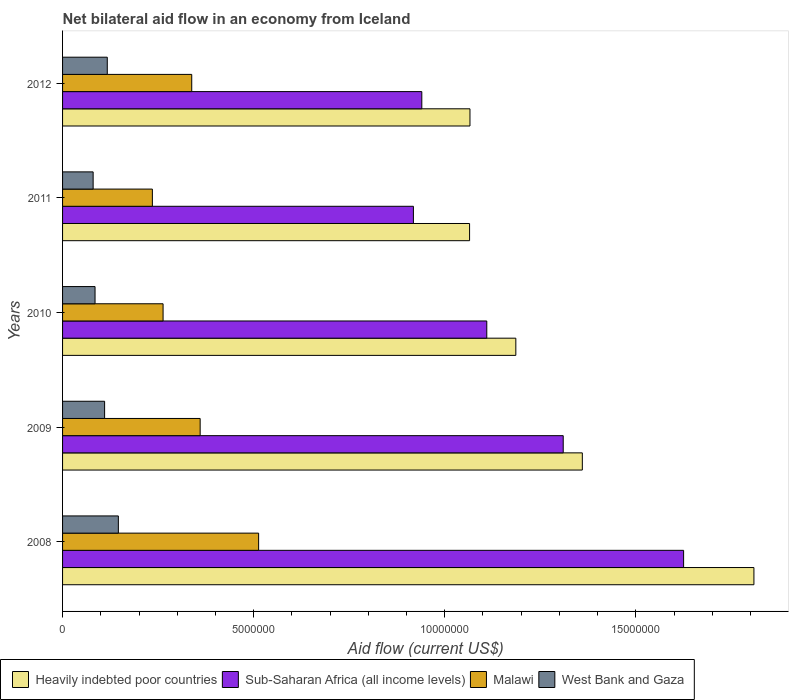How many different coloured bars are there?
Provide a succinct answer. 4. How many bars are there on the 3rd tick from the top?
Your answer should be compact. 4. How many bars are there on the 1st tick from the bottom?
Make the answer very short. 4. In how many cases, is the number of bars for a given year not equal to the number of legend labels?
Your response must be concise. 0. What is the net bilateral aid flow in Sub-Saharan Africa (all income levels) in 2011?
Provide a succinct answer. 9.18e+06. Across all years, what is the maximum net bilateral aid flow in Malawi?
Your answer should be very brief. 5.13e+06. Across all years, what is the minimum net bilateral aid flow in Sub-Saharan Africa (all income levels)?
Offer a very short reply. 9.18e+06. In which year was the net bilateral aid flow in Sub-Saharan Africa (all income levels) minimum?
Your answer should be compact. 2011. What is the total net bilateral aid flow in West Bank and Gaza in the graph?
Ensure brevity in your answer.  5.38e+06. What is the difference between the net bilateral aid flow in Malawi in 2008 and that in 2012?
Your response must be concise. 1.75e+06. What is the difference between the net bilateral aid flow in Malawi in 2008 and the net bilateral aid flow in Sub-Saharan Africa (all income levels) in 2012?
Your answer should be very brief. -4.27e+06. What is the average net bilateral aid flow in West Bank and Gaza per year?
Provide a succinct answer. 1.08e+06. In the year 2012, what is the difference between the net bilateral aid flow in Heavily indebted poor countries and net bilateral aid flow in West Bank and Gaza?
Offer a terse response. 9.49e+06. In how many years, is the net bilateral aid flow in Heavily indebted poor countries greater than 7000000 US$?
Keep it short and to the point. 5. What is the ratio of the net bilateral aid flow in Malawi in 2010 to that in 2011?
Offer a terse response. 1.12. What is the difference between the highest and the second highest net bilateral aid flow in Heavily indebted poor countries?
Make the answer very short. 4.49e+06. In how many years, is the net bilateral aid flow in Heavily indebted poor countries greater than the average net bilateral aid flow in Heavily indebted poor countries taken over all years?
Your answer should be very brief. 2. What does the 2nd bar from the top in 2012 represents?
Your answer should be very brief. Malawi. What does the 4th bar from the bottom in 2011 represents?
Ensure brevity in your answer.  West Bank and Gaza. Are all the bars in the graph horizontal?
Provide a succinct answer. Yes. How many years are there in the graph?
Offer a terse response. 5. How are the legend labels stacked?
Your answer should be very brief. Horizontal. What is the title of the graph?
Provide a succinct answer. Net bilateral aid flow in an economy from Iceland. Does "Burkina Faso" appear as one of the legend labels in the graph?
Provide a short and direct response. No. What is the label or title of the X-axis?
Give a very brief answer. Aid flow (current US$). What is the label or title of the Y-axis?
Your answer should be very brief. Years. What is the Aid flow (current US$) in Heavily indebted poor countries in 2008?
Provide a short and direct response. 1.81e+07. What is the Aid flow (current US$) of Sub-Saharan Africa (all income levels) in 2008?
Your response must be concise. 1.62e+07. What is the Aid flow (current US$) in Malawi in 2008?
Ensure brevity in your answer.  5.13e+06. What is the Aid flow (current US$) in West Bank and Gaza in 2008?
Provide a short and direct response. 1.46e+06. What is the Aid flow (current US$) of Heavily indebted poor countries in 2009?
Provide a short and direct response. 1.36e+07. What is the Aid flow (current US$) in Sub-Saharan Africa (all income levels) in 2009?
Your response must be concise. 1.31e+07. What is the Aid flow (current US$) in Malawi in 2009?
Offer a very short reply. 3.60e+06. What is the Aid flow (current US$) of West Bank and Gaza in 2009?
Offer a very short reply. 1.10e+06. What is the Aid flow (current US$) of Heavily indebted poor countries in 2010?
Your response must be concise. 1.19e+07. What is the Aid flow (current US$) of Sub-Saharan Africa (all income levels) in 2010?
Your answer should be compact. 1.11e+07. What is the Aid flow (current US$) of Malawi in 2010?
Your answer should be very brief. 2.63e+06. What is the Aid flow (current US$) of West Bank and Gaza in 2010?
Offer a very short reply. 8.50e+05. What is the Aid flow (current US$) of Heavily indebted poor countries in 2011?
Give a very brief answer. 1.06e+07. What is the Aid flow (current US$) of Sub-Saharan Africa (all income levels) in 2011?
Your response must be concise. 9.18e+06. What is the Aid flow (current US$) in Malawi in 2011?
Ensure brevity in your answer.  2.35e+06. What is the Aid flow (current US$) in Heavily indebted poor countries in 2012?
Your answer should be compact. 1.07e+07. What is the Aid flow (current US$) in Sub-Saharan Africa (all income levels) in 2012?
Your answer should be very brief. 9.40e+06. What is the Aid flow (current US$) in Malawi in 2012?
Ensure brevity in your answer.  3.38e+06. What is the Aid flow (current US$) of West Bank and Gaza in 2012?
Offer a very short reply. 1.17e+06. Across all years, what is the maximum Aid flow (current US$) in Heavily indebted poor countries?
Provide a succinct answer. 1.81e+07. Across all years, what is the maximum Aid flow (current US$) of Sub-Saharan Africa (all income levels)?
Offer a terse response. 1.62e+07. Across all years, what is the maximum Aid flow (current US$) in Malawi?
Provide a succinct answer. 5.13e+06. Across all years, what is the maximum Aid flow (current US$) of West Bank and Gaza?
Your answer should be very brief. 1.46e+06. Across all years, what is the minimum Aid flow (current US$) of Heavily indebted poor countries?
Offer a very short reply. 1.06e+07. Across all years, what is the minimum Aid flow (current US$) of Sub-Saharan Africa (all income levels)?
Make the answer very short. 9.18e+06. Across all years, what is the minimum Aid flow (current US$) of Malawi?
Make the answer very short. 2.35e+06. What is the total Aid flow (current US$) in Heavily indebted poor countries in the graph?
Give a very brief answer. 6.49e+07. What is the total Aid flow (current US$) of Sub-Saharan Africa (all income levels) in the graph?
Your answer should be very brief. 5.90e+07. What is the total Aid flow (current US$) in Malawi in the graph?
Give a very brief answer. 1.71e+07. What is the total Aid flow (current US$) in West Bank and Gaza in the graph?
Give a very brief answer. 5.38e+06. What is the difference between the Aid flow (current US$) in Heavily indebted poor countries in 2008 and that in 2009?
Provide a succinct answer. 4.49e+06. What is the difference between the Aid flow (current US$) of Sub-Saharan Africa (all income levels) in 2008 and that in 2009?
Your answer should be very brief. 3.15e+06. What is the difference between the Aid flow (current US$) of Malawi in 2008 and that in 2009?
Provide a succinct answer. 1.53e+06. What is the difference between the Aid flow (current US$) in Heavily indebted poor countries in 2008 and that in 2010?
Your answer should be very brief. 6.23e+06. What is the difference between the Aid flow (current US$) in Sub-Saharan Africa (all income levels) in 2008 and that in 2010?
Your response must be concise. 5.15e+06. What is the difference between the Aid flow (current US$) of Malawi in 2008 and that in 2010?
Provide a short and direct response. 2.50e+06. What is the difference between the Aid flow (current US$) of Heavily indebted poor countries in 2008 and that in 2011?
Your answer should be very brief. 7.44e+06. What is the difference between the Aid flow (current US$) of Sub-Saharan Africa (all income levels) in 2008 and that in 2011?
Ensure brevity in your answer.  7.07e+06. What is the difference between the Aid flow (current US$) of Malawi in 2008 and that in 2011?
Ensure brevity in your answer.  2.78e+06. What is the difference between the Aid flow (current US$) in Heavily indebted poor countries in 2008 and that in 2012?
Provide a short and direct response. 7.43e+06. What is the difference between the Aid flow (current US$) of Sub-Saharan Africa (all income levels) in 2008 and that in 2012?
Make the answer very short. 6.85e+06. What is the difference between the Aid flow (current US$) of Malawi in 2008 and that in 2012?
Make the answer very short. 1.75e+06. What is the difference between the Aid flow (current US$) of West Bank and Gaza in 2008 and that in 2012?
Provide a succinct answer. 2.90e+05. What is the difference between the Aid flow (current US$) of Heavily indebted poor countries in 2009 and that in 2010?
Keep it short and to the point. 1.74e+06. What is the difference between the Aid flow (current US$) of Sub-Saharan Africa (all income levels) in 2009 and that in 2010?
Give a very brief answer. 2.00e+06. What is the difference between the Aid flow (current US$) in Malawi in 2009 and that in 2010?
Your answer should be very brief. 9.70e+05. What is the difference between the Aid flow (current US$) of West Bank and Gaza in 2009 and that in 2010?
Make the answer very short. 2.50e+05. What is the difference between the Aid flow (current US$) of Heavily indebted poor countries in 2009 and that in 2011?
Provide a succinct answer. 2.95e+06. What is the difference between the Aid flow (current US$) in Sub-Saharan Africa (all income levels) in 2009 and that in 2011?
Your answer should be very brief. 3.92e+06. What is the difference between the Aid flow (current US$) in Malawi in 2009 and that in 2011?
Your answer should be very brief. 1.25e+06. What is the difference between the Aid flow (current US$) in West Bank and Gaza in 2009 and that in 2011?
Offer a terse response. 3.00e+05. What is the difference between the Aid flow (current US$) of Heavily indebted poor countries in 2009 and that in 2012?
Keep it short and to the point. 2.94e+06. What is the difference between the Aid flow (current US$) in Sub-Saharan Africa (all income levels) in 2009 and that in 2012?
Your answer should be very brief. 3.70e+06. What is the difference between the Aid flow (current US$) of Malawi in 2009 and that in 2012?
Keep it short and to the point. 2.20e+05. What is the difference between the Aid flow (current US$) of Heavily indebted poor countries in 2010 and that in 2011?
Keep it short and to the point. 1.21e+06. What is the difference between the Aid flow (current US$) in Sub-Saharan Africa (all income levels) in 2010 and that in 2011?
Provide a short and direct response. 1.92e+06. What is the difference between the Aid flow (current US$) of West Bank and Gaza in 2010 and that in 2011?
Give a very brief answer. 5.00e+04. What is the difference between the Aid flow (current US$) in Heavily indebted poor countries in 2010 and that in 2012?
Provide a short and direct response. 1.20e+06. What is the difference between the Aid flow (current US$) of Sub-Saharan Africa (all income levels) in 2010 and that in 2012?
Provide a succinct answer. 1.70e+06. What is the difference between the Aid flow (current US$) of Malawi in 2010 and that in 2012?
Make the answer very short. -7.50e+05. What is the difference between the Aid flow (current US$) of West Bank and Gaza in 2010 and that in 2012?
Offer a very short reply. -3.20e+05. What is the difference between the Aid flow (current US$) in Heavily indebted poor countries in 2011 and that in 2012?
Keep it short and to the point. -10000. What is the difference between the Aid flow (current US$) in Sub-Saharan Africa (all income levels) in 2011 and that in 2012?
Offer a very short reply. -2.20e+05. What is the difference between the Aid flow (current US$) of Malawi in 2011 and that in 2012?
Your response must be concise. -1.03e+06. What is the difference between the Aid flow (current US$) of West Bank and Gaza in 2011 and that in 2012?
Provide a succinct answer. -3.70e+05. What is the difference between the Aid flow (current US$) in Heavily indebted poor countries in 2008 and the Aid flow (current US$) in Sub-Saharan Africa (all income levels) in 2009?
Your response must be concise. 4.99e+06. What is the difference between the Aid flow (current US$) of Heavily indebted poor countries in 2008 and the Aid flow (current US$) of Malawi in 2009?
Offer a terse response. 1.45e+07. What is the difference between the Aid flow (current US$) of Heavily indebted poor countries in 2008 and the Aid flow (current US$) of West Bank and Gaza in 2009?
Keep it short and to the point. 1.70e+07. What is the difference between the Aid flow (current US$) in Sub-Saharan Africa (all income levels) in 2008 and the Aid flow (current US$) in Malawi in 2009?
Offer a very short reply. 1.26e+07. What is the difference between the Aid flow (current US$) of Sub-Saharan Africa (all income levels) in 2008 and the Aid flow (current US$) of West Bank and Gaza in 2009?
Offer a very short reply. 1.52e+07. What is the difference between the Aid flow (current US$) of Malawi in 2008 and the Aid flow (current US$) of West Bank and Gaza in 2009?
Keep it short and to the point. 4.03e+06. What is the difference between the Aid flow (current US$) in Heavily indebted poor countries in 2008 and the Aid flow (current US$) in Sub-Saharan Africa (all income levels) in 2010?
Your response must be concise. 6.99e+06. What is the difference between the Aid flow (current US$) in Heavily indebted poor countries in 2008 and the Aid flow (current US$) in Malawi in 2010?
Give a very brief answer. 1.55e+07. What is the difference between the Aid flow (current US$) in Heavily indebted poor countries in 2008 and the Aid flow (current US$) in West Bank and Gaza in 2010?
Make the answer very short. 1.72e+07. What is the difference between the Aid flow (current US$) in Sub-Saharan Africa (all income levels) in 2008 and the Aid flow (current US$) in Malawi in 2010?
Your answer should be compact. 1.36e+07. What is the difference between the Aid flow (current US$) of Sub-Saharan Africa (all income levels) in 2008 and the Aid flow (current US$) of West Bank and Gaza in 2010?
Your answer should be compact. 1.54e+07. What is the difference between the Aid flow (current US$) in Malawi in 2008 and the Aid flow (current US$) in West Bank and Gaza in 2010?
Provide a succinct answer. 4.28e+06. What is the difference between the Aid flow (current US$) in Heavily indebted poor countries in 2008 and the Aid flow (current US$) in Sub-Saharan Africa (all income levels) in 2011?
Offer a very short reply. 8.91e+06. What is the difference between the Aid flow (current US$) of Heavily indebted poor countries in 2008 and the Aid flow (current US$) of Malawi in 2011?
Provide a short and direct response. 1.57e+07. What is the difference between the Aid flow (current US$) in Heavily indebted poor countries in 2008 and the Aid flow (current US$) in West Bank and Gaza in 2011?
Provide a short and direct response. 1.73e+07. What is the difference between the Aid flow (current US$) in Sub-Saharan Africa (all income levels) in 2008 and the Aid flow (current US$) in Malawi in 2011?
Your answer should be compact. 1.39e+07. What is the difference between the Aid flow (current US$) of Sub-Saharan Africa (all income levels) in 2008 and the Aid flow (current US$) of West Bank and Gaza in 2011?
Make the answer very short. 1.54e+07. What is the difference between the Aid flow (current US$) in Malawi in 2008 and the Aid flow (current US$) in West Bank and Gaza in 2011?
Your answer should be compact. 4.33e+06. What is the difference between the Aid flow (current US$) of Heavily indebted poor countries in 2008 and the Aid flow (current US$) of Sub-Saharan Africa (all income levels) in 2012?
Your answer should be compact. 8.69e+06. What is the difference between the Aid flow (current US$) in Heavily indebted poor countries in 2008 and the Aid flow (current US$) in Malawi in 2012?
Make the answer very short. 1.47e+07. What is the difference between the Aid flow (current US$) in Heavily indebted poor countries in 2008 and the Aid flow (current US$) in West Bank and Gaza in 2012?
Provide a succinct answer. 1.69e+07. What is the difference between the Aid flow (current US$) of Sub-Saharan Africa (all income levels) in 2008 and the Aid flow (current US$) of Malawi in 2012?
Your answer should be compact. 1.29e+07. What is the difference between the Aid flow (current US$) in Sub-Saharan Africa (all income levels) in 2008 and the Aid flow (current US$) in West Bank and Gaza in 2012?
Make the answer very short. 1.51e+07. What is the difference between the Aid flow (current US$) of Malawi in 2008 and the Aid flow (current US$) of West Bank and Gaza in 2012?
Provide a succinct answer. 3.96e+06. What is the difference between the Aid flow (current US$) of Heavily indebted poor countries in 2009 and the Aid flow (current US$) of Sub-Saharan Africa (all income levels) in 2010?
Make the answer very short. 2.50e+06. What is the difference between the Aid flow (current US$) of Heavily indebted poor countries in 2009 and the Aid flow (current US$) of Malawi in 2010?
Ensure brevity in your answer.  1.10e+07. What is the difference between the Aid flow (current US$) in Heavily indebted poor countries in 2009 and the Aid flow (current US$) in West Bank and Gaza in 2010?
Provide a succinct answer. 1.28e+07. What is the difference between the Aid flow (current US$) in Sub-Saharan Africa (all income levels) in 2009 and the Aid flow (current US$) in Malawi in 2010?
Offer a terse response. 1.05e+07. What is the difference between the Aid flow (current US$) of Sub-Saharan Africa (all income levels) in 2009 and the Aid flow (current US$) of West Bank and Gaza in 2010?
Your answer should be very brief. 1.22e+07. What is the difference between the Aid flow (current US$) of Malawi in 2009 and the Aid flow (current US$) of West Bank and Gaza in 2010?
Provide a succinct answer. 2.75e+06. What is the difference between the Aid flow (current US$) in Heavily indebted poor countries in 2009 and the Aid flow (current US$) in Sub-Saharan Africa (all income levels) in 2011?
Give a very brief answer. 4.42e+06. What is the difference between the Aid flow (current US$) of Heavily indebted poor countries in 2009 and the Aid flow (current US$) of Malawi in 2011?
Your answer should be very brief. 1.12e+07. What is the difference between the Aid flow (current US$) of Heavily indebted poor countries in 2009 and the Aid flow (current US$) of West Bank and Gaza in 2011?
Provide a succinct answer. 1.28e+07. What is the difference between the Aid flow (current US$) in Sub-Saharan Africa (all income levels) in 2009 and the Aid flow (current US$) in Malawi in 2011?
Offer a terse response. 1.08e+07. What is the difference between the Aid flow (current US$) of Sub-Saharan Africa (all income levels) in 2009 and the Aid flow (current US$) of West Bank and Gaza in 2011?
Make the answer very short. 1.23e+07. What is the difference between the Aid flow (current US$) in Malawi in 2009 and the Aid flow (current US$) in West Bank and Gaza in 2011?
Provide a succinct answer. 2.80e+06. What is the difference between the Aid flow (current US$) in Heavily indebted poor countries in 2009 and the Aid flow (current US$) in Sub-Saharan Africa (all income levels) in 2012?
Ensure brevity in your answer.  4.20e+06. What is the difference between the Aid flow (current US$) in Heavily indebted poor countries in 2009 and the Aid flow (current US$) in Malawi in 2012?
Offer a very short reply. 1.02e+07. What is the difference between the Aid flow (current US$) in Heavily indebted poor countries in 2009 and the Aid flow (current US$) in West Bank and Gaza in 2012?
Ensure brevity in your answer.  1.24e+07. What is the difference between the Aid flow (current US$) in Sub-Saharan Africa (all income levels) in 2009 and the Aid flow (current US$) in Malawi in 2012?
Provide a short and direct response. 9.72e+06. What is the difference between the Aid flow (current US$) in Sub-Saharan Africa (all income levels) in 2009 and the Aid flow (current US$) in West Bank and Gaza in 2012?
Your answer should be very brief. 1.19e+07. What is the difference between the Aid flow (current US$) in Malawi in 2009 and the Aid flow (current US$) in West Bank and Gaza in 2012?
Your response must be concise. 2.43e+06. What is the difference between the Aid flow (current US$) of Heavily indebted poor countries in 2010 and the Aid flow (current US$) of Sub-Saharan Africa (all income levels) in 2011?
Your response must be concise. 2.68e+06. What is the difference between the Aid flow (current US$) in Heavily indebted poor countries in 2010 and the Aid flow (current US$) in Malawi in 2011?
Ensure brevity in your answer.  9.51e+06. What is the difference between the Aid flow (current US$) in Heavily indebted poor countries in 2010 and the Aid flow (current US$) in West Bank and Gaza in 2011?
Your answer should be compact. 1.11e+07. What is the difference between the Aid flow (current US$) of Sub-Saharan Africa (all income levels) in 2010 and the Aid flow (current US$) of Malawi in 2011?
Your answer should be compact. 8.75e+06. What is the difference between the Aid flow (current US$) of Sub-Saharan Africa (all income levels) in 2010 and the Aid flow (current US$) of West Bank and Gaza in 2011?
Your answer should be compact. 1.03e+07. What is the difference between the Aid flow (current US$) of Malawi in 2010 and the Aid flow (current US$) of West Bank and Gaza in 2011?
Offer a very short reply. 1.83e+06. What is the difference between the Aid flow (current US$) in Heavily indebted poor countries in 2010 and the Aid flow (current US$) in Sub-Saharan Africa (all income levels) in 2012?
Provide a succinct answer. 2.46e+06. What is the difference between the Aid flow (current US$) in Heavily indebted poor countries in 2010 and the Aid flow (current US$) in Malawi in 2012?
Make the answer very short. 8.48e+06. What is the difference between the Aid flow (current US$) of Heavily indebted poor countries in 2010 and the Aid flow (current US$) of West Bank and Gaza in 2012?
Make the answer very short. 1.07e+07. What is the difference between the Aid flow (current US$) of Sub-Saharan Africa (all income levels) in 2010 and the Aid flow (current US$) of Malawi in 2012?
Offer a terse response. 7.72e+06. What is the difference between the Aid flow (current US$) of Sub-Saharan Africa (all income levels) in 2010 and the Aid flow (current US$) of West Bank and Gaza in 2012?
Your answer should be very brief. 9.93e+06. What is the difference between the Aid flow (current US$) of Malawi in 2010 and the Aid flow (current US$) of West Bank and Gaza in 2012?
Your response must be concise. 1.46e+06. What is the difference between the Aid flow (current US$) in Heavily indebted poor countries in 2011 and the Aid flow (current US$) in Sub-Saharan Africa (all income levels) in 2012?
Your answer should be very brief. 1.25e+06. What is the difference between the Aid flow (current US$) of Heavily indebted poor countries in 2011 and the Aid flow (current US$) of Malawi in 2012?
Your answer should be compact. 7.27e+06. What is the difference between the Aid flow (current US$) in Heavily indebted poor countries in 2011 and the Aid flow (current US$) in West Bank and Gaza in 2012?
Ensure brevity in your answer.  9.48e+06. What is the difference between the Aid flow (current US$) of Sub-Saharan Africa (all income levels) in 2011 and the Aid flow (current US$) of Malawi in 2012?
Ensure brevity in your answer.  5.80e+06. What is the difference between the Aid flow (current US$) in Sub-Saharan Africa (all income levels) in 2011 and the Aid flow (current US$) in West Bank and Gaza in 2012?
Provide a succinct answer. 8.01e+06. What is the difference between the Aid flow (current US$) of Malawi in 2011 and the Aid flow (current US$) of West Bank and Gaza in 2012?
Provide a succinct answer. 1.18e+06. What is the average Aid flow (current US$) of Heavily indebted poor countries per year?
Provide a short and direct response. 1.30e+07. What is the average Aid flow (current US$) of Sub-Saharan Africa (all income levels) per year?
Your response must be concise. 1.18e+07. What is the average Aid flow (current US$) of Malawi per year?
Keep it short and to the point. 3.42e+06. What is the average Aid flow (current US$) in West Bank and Gaza per year?
Give a very brief answer. 1.08e+06. In the year 2008, what is the difference between the Aid flow (current US$) in Heavily indebted poor countries and Aid flow (current US$) in Sub-Saharan Africa (all income levels)?
Provide a short and direct response. 1.84e+06. In the year 2008, what is the difference between the Aid flow (current US$) in Heavily indebted poor countries and Aid flow (current US$) in Malawi?
Your answer should be compact. 1.30e+07. In the year 2008, what is the difference between the Aid flow (current US$) in Heavily indebted poor countries and Aid flow (current US$) in West Bank and Gaza?
Your answer should be very brief. 1.66e+07. In the year 2008, what is the difference between the Aid flow (current US$) of Sub-Saharan Africa (all income levels) and Aid flow (current US$) of Malawi?
Ensure brevity in your answer.  1.11e+07. In the year 2008, what is the difference between the Aid flow (current US$) in Sub-Saharan Africa (all income levels) and Aid flow (current US$) in West Bank and Gaza?
Your response must be concise. 1.48e+07. In the year 2008, what is the difference between the Aid flow (current US$) in Malawi and Aid flow (current US$) in West Bank and Gaza?
Your answer should be compact. 3.67e+06. In the year 2009, what is the difference between the Aid flow (current US$) of Heavily indebted poor countries and Aid flow (current US$) of West Bank and Gaza?
Offer a very short reply. 1.25e+07. In the year 2009, what is the difference between the Aid flow (current US$) of Sub-Saharan Africa (all income levels) and Aid flow (current US$) of Malawi?
Ensure brevity in your answer.  9.50e+06. In the year 2009, what is the difference between the Aid flow (current US$) of Malawi and Aid flow (current US$) of West Bank and Gaza?
Make the answer very short. 2.50e+06. In the year 2010, what is the difference between the Aid flow (current US$) in Heavily indebted poor countries and Aid flow (current US$) in Sub-Saharan Africa (all income levels)?
Your answer should be compact. 7.60e+05. In the year 2010, what is the difference between the Aid flow (current US$) of Heavily indebted poor countries and Aid flow (current US$) of Malawi?
Keep it short and to the point. 9.23e+06. In the year 2010, what is the difference between the Aid flow (current US$) in Heavily indebted poor countries and Aid flow (current US$) in West Bank and Gaza?
Keep it short and to the point. 1.10e+07. In the year 2010, what is the difference between the Aid flow (current US$) in Sub-Saharan Africa (all income levels) and Aid flow (current US$) in Malawi?
Offer a very short reply. 8.47e+06. In the year 2010, what is the difference between the Aid flow (current US$) in Sub-Saharan Africa (all income levels) and Aid flow (current US$) in West Bank and Gaza?
Offer a very short reply. 1.02e+07. In the year 2010, what is the difference between the Aid flow (current US$) of Malawi and Aid flow (current US$) of West Bank and Gaza?
Offer a terse response. 1.78e+06. In the year 2011, what is the difference between the Aid flow (current US$) of Heavily indebted poor countries and Aid flow (current US$) of Sub-Saharan Africa (all income levels)?
Your answer should be very brief. 1.47e+06. In the year 2011, what is the difference between the Aid flow (current US$) in Heavily indebted poor countries and Aid flow (current US$) in Malawi?
Give a very brief answer. 8.30e+06. In the year 2011, what is the difference between the Aid flow (current US$) in Heavily indebted poor countries and Aid flow (current US$) in West Bank and Gaza?
Keep it short and to the point. 9.85e+06. In the year 2011, what is the difference between the Aid flow (current US$) in Sub-Saharan Africa (all income levels) and Aid flow (current US$) in Malawi?
Make the answer very short. 6.83e+06. In the year 2011, what is the difference between the Aid flow (current US$) of Sub-Saharan Africa (all income levels) and Aid flow (current US$) of West Bank and Gaza?
Make the answer very short. 8.38e+06. In the year 2011, what is the difference between the Aid flow (current US$) of Malawi and Aid flow (current US$) of West Bank and Gaza?
Offer a very short reply. 1.55e+06. In the year 2012, what is the difference between the Aid flow (current US$) in Heavily indebted poor countries and Aid flow (current US$) in Sub-Saharan Africa (all income levels)?
Give a very brief answer. 1.26e+06. In the year 2012, what is the difference between the Aid flow (current US$) of Heavily indebted poor countries and Aid flow (current US$) of Malawi?
Provide a short and direct response. 7.28e+06. In the year 2012, what is the difference between the Aid flow (current US$) in Heavily indebted poor countries and Aid flow (current US$) in West Bank and Gaza?
Offer a very short reply. 9.49e+06. In the year 2012, what is the difference between the Aid flow (current US$) in Sub-Saharan Africa (all income levels) and Aid flow (current US$) in Malawi?
Your response must be concise. 6.02e+06. In the year 2012, what is the difference between the Aid flow (current US$) of Sub-Saharan Africa (all income levels) and Aid flow (current US$) of West Bank and Gaza?
Make the answer very short. 8.23e+06. In the year 2012, what is the difference between the Aid flow (current US$) of Malawi and Aid flow (current US$) of West Bank and Gaza?
Offer a very short reply. 2.21e+06. What is the ratio of the Aid flow (current US$) of Heavily indebted poor countries in 2008 to that in 2009?
Your answer should be very brief. 1.33. What is the ratio of the Aid flow (current US$) of Sub-Saharan Africa (all income levels) in 2008 to that in 2009?
Your answer should be compact. 1.24. What is the ratio of the Aid flow (current US$) in Malawi in 2008 to that in 2009?
Make the answer very short. 1.43. What is the ratio of the Aid flow (current US$) in West Bank and Gaza in 2008 to that in 2009?
Provide a succinct answer. 1.33. What is the ratio of the Aid flow (current US$) in Heavily indebted poor countries in 2008 to that in 2010?
Offer a very short reply. 1.53. What is the ratio of the Aid flow (current US$) in Sub-Saharan Africa (all income levels) in 2008 to that in 2010?
Give a very brief answer. 1.46. What is the ratio of the Aid flow (current US$) of Malawi in 2008 to that in 2010?
Provide a succinct answer. 1.95. What is the ratio of the Aid flow (current US$) of West Bank and Gaza in 2008 to that in 2010?
Give a very brief answer. 1.72. What is the ratio of the Aid flow (current US$) of Heavily indebted poor countries in 2008 to that in 2011?
Your answer should be compact. 1.7. What is the ratio of the Aid flow (current US$) in Sub-Saharan Africa (all income levels) in 2008 to that in 2011?
Provide a succinct answer. 1.77. What is the ratio of the Aid flow (current US$) in Malawi in 2008 to that in 2011?
Keep it short and to the point. 2.18. What is the ratio of the Aid flow (current US$) in West Bank and Gaza in 2008 to that in 2011?
Give a very brief answer. 1.82. What is the ratio of the Aid flow (current US$) in Heavily indebted poor countries in 2008 to that in 2012?
Make the answer very short. 1.7. What is the ratio of the Aid flow (current US$) in Sub-Saharan Africa (all income levels) in 2008 to that in 2012?
Offer a terse response. 1.73. What is the ratio of the Aid flow (current US$) of Malawi in 2008 to that in 2012?
Ensure brevity in your answer.  1.52. What is the ratio of the Aid flow (current US$) in West Bank and Gaza in 2008 to that in 2012?
Your answer should be very brief. 1.25. What is the ratio of the Aid flow (current US$) of Heavily indebted poor countries in 2009 to that in 2010?
Offer a very short reply. 1.15. What is the ratio of the Aid flow (current US$) of Sub-Saharan Africa (all income levels) in 2009 to that in 2010?
Provide a succinct answer. 1.18. What is the ratio of the Aid flow (current US$) of Malawi in 2009 to that in 2010?
Provide a short and direct response. 1.37. What is the ratio of the Aid flow (current US$) in West Bank and Gaza in 2009 to that in 2010?
Offer a very short reply. 1.29. What is the ratio of the Aid flow (current US$) in Heavily indebted poor countries in 2009 to that in 2011?
Give a very brief answer. 1.28. What is the ratio of the Aid flow (current US$) of Sub-Saharan Africa (all income levels) in 2009 to that in 2011?
Your response must be concise. 1.43. What is the ratio of the Aid flow (current US$) of Malawi in 2009 to that in 2011?
Your answer should be very brief. 1.53. What is the ratio of the Aid flow (current US$) in West Bank and Gaza in 2009 to that in 2011?
Your answer should be very brief. 1.38. What is the ratio of the Aid flow (current US$) of Heavily indebted poor countries in 2009 to that in 2012?
Provide a short and direct response. 1.28. What is the ratio of the Aid flow (current US$) of Sub-Saharan Africa (all income levels) in 2009 to that in 2012?
Offer a very short reply. 1.39. What is the ratio of the Aid flow (current US$) of Malawi in 2009 to that in 2012?
Offer a very short reply. 1.07. What is the ratio of the Aid flow (current US$) in West Bank and Gaza in 2009 to that in 2012?
Keep it short and to the point. 0.94. What is the ratio of the Aid flow (current US$) of Heavily indebted poor countries in 2010 to that in 2011?
Offer a terse response. 1.11. What is the ratio of the Aid flow (current US$) of Sub-Saharan Africa (all income levels) in 2010 to that in 2011?
Your answer should be compact. 1.21. What is the ratio of the Aid flow (current US$) in Malawi in 2010 to that in 2011?
Your response must be concise. 1.12. What is the ratio of the Aid flow (current US$) in Heavily indebted poor countries in 2010 to that in 2012?
Give a very brief answer. 1.11. What is the ratio of the Aid flow (current US$) of Sub-Saharan Africa (all income levels) in 2010 to that in 2012?
Provide a short and direct response. 1.18. What is the ratio of the Aid flow (current US$) in Malawi in 2010 to that in 2012?
Give a very brief answer. 0.78. What is the ratio of the Aid flow (current US$) in West Bank and Gaza in 2010 to that in 2012?
Offer a very short reply. 0.73. What is the ratio of the Aid flow (current US$) of Heavily indebted poor countries in 2011 to that in 2012?
Keep it short and to the point. 1. What is the ratio of the Aid flow (current US$) in Sub-Saharan Africa (all income levels) in 2011 to that in 2012?
Provide a succinct answer. 0.98. What is the ratio of the Aid flow (current US$) of Malawi in 2011 to that in 2012?
Offer a terse response. 0.7. What is the ratio of the Aid flow (current US$) of West Bank and Gaza in 2011 to that in 2012?
Provide a succinct answer. 0.68. What is the difference between the highest and the second highest Aid flow (current US$) in Heavily indebted poor countries?
Keep it short and to the point. 4.49e+06. What is the difference between the highest and the second highest Aid flow (current US$) in Sub-Saharan Africa (all income levels)?
Your answer should be compact. 3.15e+06. What is the difference between the highest and the second highest Aid flow (current US$) of Malawi?
Your response must be concise. 1.53e+06. What is the difference between the highest and the lowest Aid flow (current US$) in Heavily indebted poor countries?
Offer a very short reply. 7.44e+06. What is the difference between the highest and the lowest Aid flow (current US$) of Sub-Saharan Africa (all income levels)?
Offer a terse response. 7.07e+06. What is the difference between the highest and the lowest Aid flow (current US$) of Malawi?
Provide a short and direct response. 2.78e+06. What is the difference between the highest and the lowest Aid flow (current US$) in West Bank and Gaza?
Offer a terse response. 6.60e+05. 